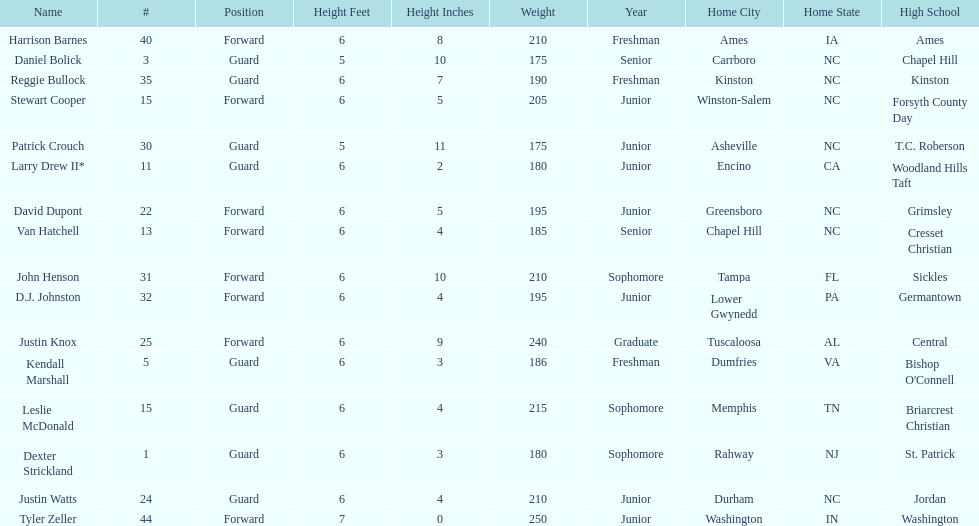Who was taller, justin knox or john henson? John Henson. 